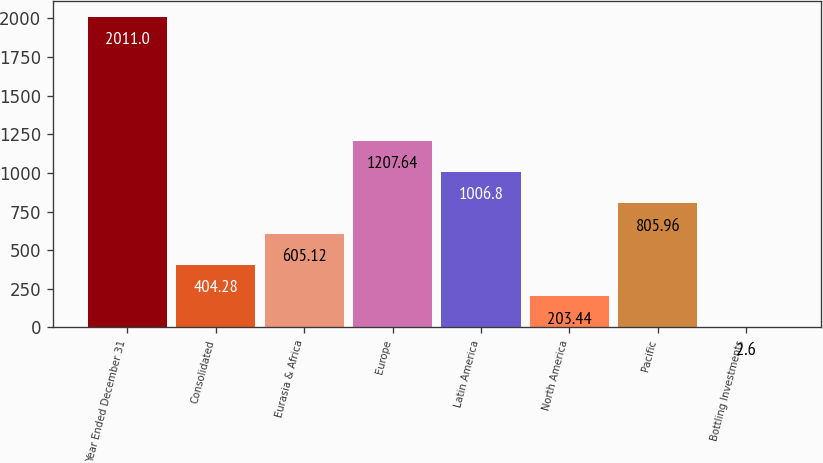Convert chart. <chart><loc_0><loc_0><loc_500><loc_500><bar_chart><fcel>Year Ended December 31<fcel>Consolidated<fcel>Eurasia & Africa<fcel>Europe<fcel>Latin America<fcel>North America<fcel>Pacific<fcel>Bottling Investments<nl><fcel>2011<fcel>404.28<fcel>605.12<fcel>1207.64<fcel>1006.8<fcel>203.44<fcel>805.96<fcel>2.6<nl></chart> 